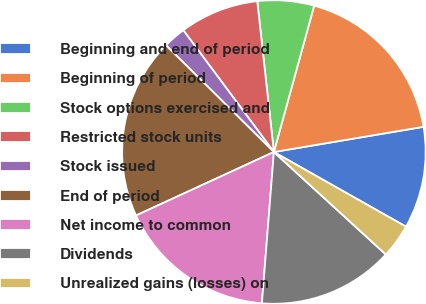Convert chart to OTSL. <chart><loc_0><loc_0><loc_500><loc_500><pie_chart><fcel>Beginning and end of period<fcel>Beginning of period<fcel>Stock options exercised and<fcel>Restricted stock units<fcel>Stock issued<fcel>End of period<fcel>Net income to common<fcel>Dividends<fcel>Unrealized gains (losses) on<nl><fcel>10.84%<fcel>18.07%<fcel>6.02%<fcel>8.43%<fcel>2.41%<fcel>19.28%<fcel>16.87%<fcel>14.46%<fcel>3.61%<nl></chart> 